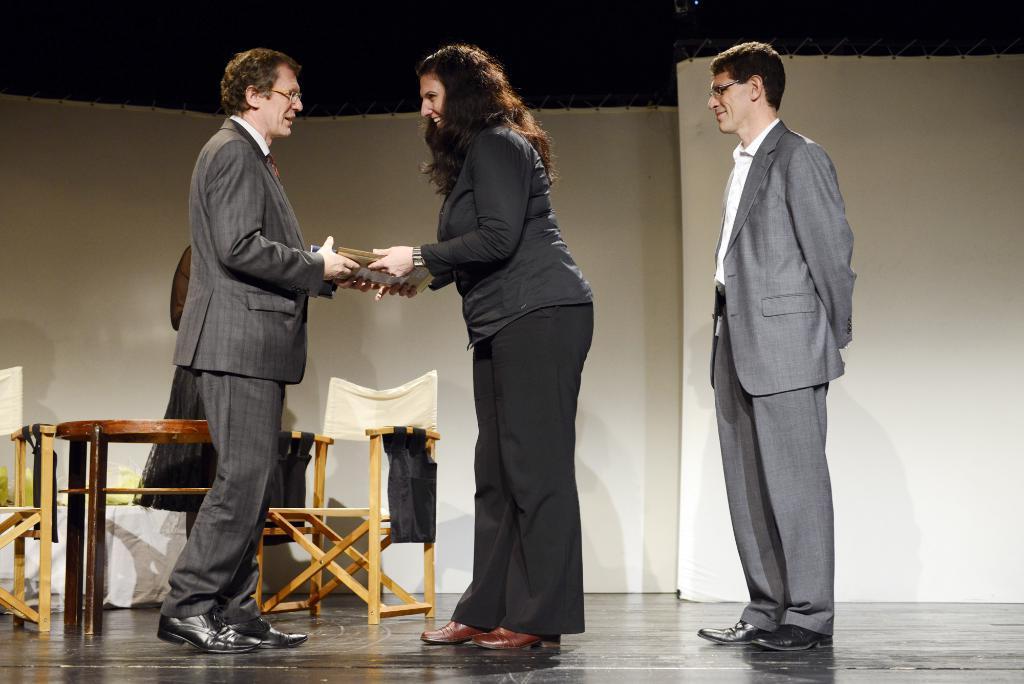How would you summarize this image in a sentence or two? This image is taken on the stage. There are four persons on the stage, two men and two woman. In the left side of the image there is a chair and a table and a person standing and holding a book. In the right side of the image a person is standing folding his hands back. In the middle of the image a woman is giving books to a man. At the background we can see a banner. 